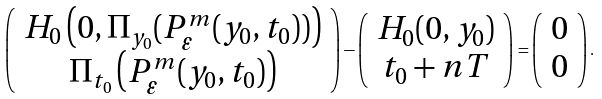Convert formula to latex. <formula><loc_0><loc_0><loc_500><loc_500>\left ( \begin{array} { c } H _ { 0 } \left ( 0 , \Pi _ { y _ { 0 } } ( P _ { \varepsilon } ^ { m } ( y _ { 0 } , t _ { 0 } ) ) \right ) \\ \Pi _ { t _ { 0 } } \left ( P ^ { m } _ { \varepsilon } ( y _ { 0 } , t _ { 0 } ) \right ) \end{array} \right ) - \left ( \begin{array} { c } H _ { 0 } ( 0 , y _ { 0 } ) \\ t _ { 0 } + n T \end{array} \right ) = \left ( \begin{array} { c } 0 \\ 0 \end{array} \right ) .</formula> 